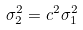Convert formula to latex. <formula><loc_0><loc_0><loc_500><loc_500>\sigma _ { 2 } ^ { 2 } = c ^ { 2 } \sigma _ { 1 } ^ { 2 }</formula> 